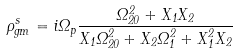Convert formula to latex. <formula><loc_0><loc_0><loc_500><loc_500>\rho _ { g m } ^ { s } = i \Omega _ { p } \frac { \Omega _ { 2 0 } ^ { 2 } + X _ { 1 } X _ { 2 } } { X _ { 1 } \Omega _ { 2 0 } ^ { 2 } + X _ { 2 } \Omega _ { 1 } ^ { 2 } + X _ { 1 } ^ { 2 } X _ { 2 } }</formula> 